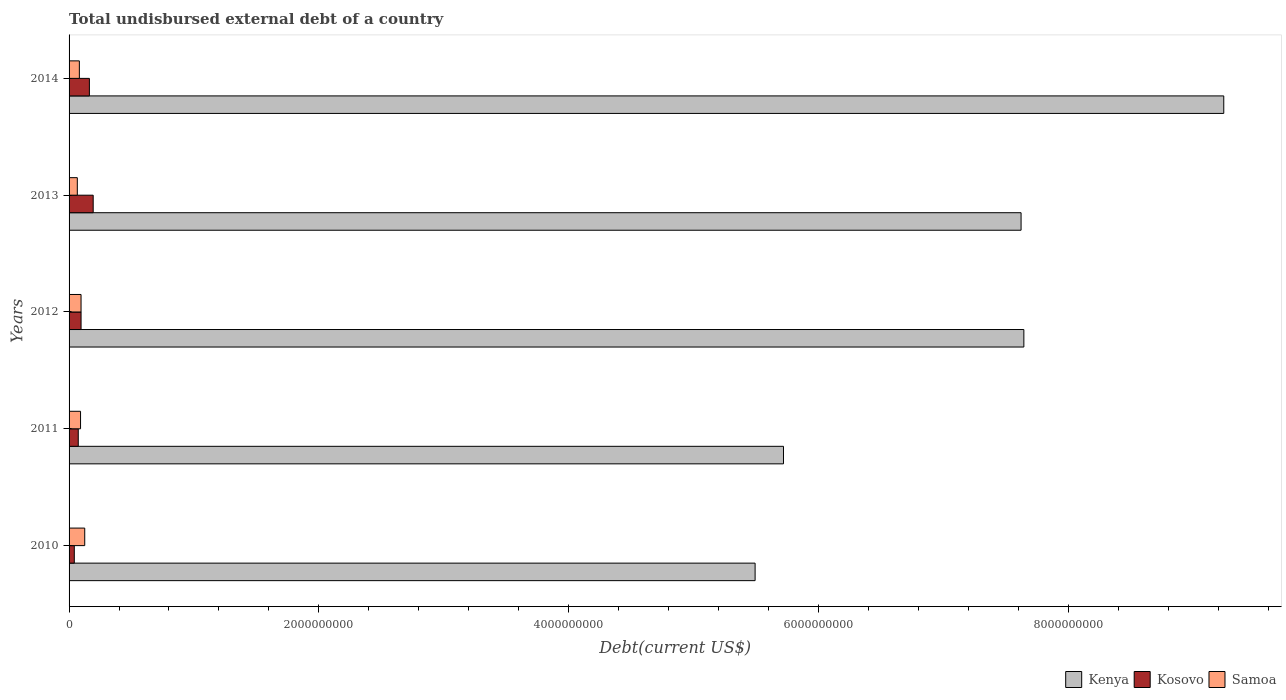How many groups of bars are there?
Keep it short and to the point. 5. How many bars are there on the 2nd tick from the bottom?
Provide a short and direct response. 3. What is the label of the 5th group of bars from the top?
Your answer should be very brief. 2010. What is the total undisbursed external debt in Kenya in 2011?
Your response must be concise. 5.72e+09. Across all years, what is the maximum total undisbursed external debt in Samoa?
Your answer should be compact. 1.25e+08. Across all years, what is the minimum total undisbursed external debt in Samoa?
Your response must be concise. 6.60e+07. In which year was the total undisbursed external debt in Kenya maximum?
Offer a very short reply. 2014. In which year was the total undisbursed external debt in Kenya minimum?
Make the answer very short. 2010. What is the total total undisbursed external debt in Kosovo in the graph?
Your response must be concise. 5.67e+08. What is the difference between the total undisbursed external debt in Kenya in 2011 and that in 2012?
Offer a very short reply. -1.92e+09. What is the difference between the total undisbursed external debt in Kosovo in 2011 and the total undisbursed external debt in Samoa in 2012?
Keep it short and to the point. -2.23e+07. What is the average total undisbursed external debt in Samoa per year?
Your response must be concise. 9.23e+07. In the year 2011, what is the difference between the total undisbursed external debt in Kosovo and total undisbursed external debt in Samoa?
Make the answer very short. -1.83e+07. What is the ratio of the total undisbursed external debt in Kosovo in 2011 to that in 2012?
Offer a terse response. 0.77. Is the difference between the total undisbursed external debt in Kosovo in 2010 and 2011 greater than the difference between the total undisbursed external debt in Samoa in 2010 and 2011?
Provide a short and direct response. No. What is the difference between the highest and the second highest total undisbursed external debt in Kosovo?
Provide a succinct answer. 3.04e+07. What is the difference between the highest and the lowest total undisbursed external debt in Samoa?
Offer a terse response. 5.94e+07. Is the sum of the total undisbursed external debt in Kosovo in 2010 and 2011 greater than the maximum total undisbursed external debt in Samoa across all years?
Provide a short and direct response. No. What does the 1st bar from the top in 2012 represents?
Offer a very short reply. Samoa. What does the 3rd bar from the bottom in 2013 represents?
Your answer should be very brief. Samoa. How many bars are there?
Your answer should be compact. 15. How many years are there in the graph?
Offer a very short reply. 5. Are the values on the major ticks of X-axis written in scientific E-notation?
Provide a succinct answer. No. Does the graph contain grids?
Make the answer very short. No. What is the title of the graph?
Ensure brevity in your answer.  Total undisbursed external debt of a country. Does "Tonga" appear as one of the legend labels in the graph?
Keep it short and to the point. No. What is the label or title of the X-axis?
Offer a very short reply. Debt(current US$). What is the label or title of the Y-axis?
Your answer should be very brief. Years. What is the Debt(current US$) in Kenya in 2010?
Ensure brevity in your answer.  5.49e+09. What is the Debt(current US$) of Kosovo in 2010?
Your answer should be very brief. 4.18e+07. What is the Debt(current US$) of Samoa in 2010?
Provide a short and direct response. 1.25e+08. What is the Debt(current US$) in Kenya in 2011?
Offer a very short reply. 5.72e+09. What is the Debt(current US$) in Kosovo in 2011?
Make the answer very short. 7.36e+07. What is the Debt(current US$) of Samoa in 2011?
Offer a terse response. 9.19e+07. What is the Debt(current US$) of Kenya in 2012?
Keep it short and to the point. 7.64e+09. What is the Debt(current US$) in Kosovo in 2012?
Give a very brief answer. 9.60e+07. What is the Debt(current US$) of Samoa in 2012?
Your answer should be very brief. 9.59e+07. What is the Debt(current US$) of Kenya in 2013?
Provide a succinct answer. 7.62e+09. What is the Debt(current US$) in Kosovo in 2013?
Your answer should be very brief. 1.93e+08. What is the Debt(current US$) in Samoa in 2013?
Provide a succinct answer. 6.60e+07. What is the Debt(current US$) of Kenya in 2014?
Keep it short and to the point. 9.25e+09. What is the Debt(current US$) in Kosovo in 2014?
Offer a very short reply. 1.63e+08. What is the Debt(current US$) of Samoa in 2014?
Provide a short and direct response. 8.24e+07. Across all years, what is the maximum Debt(current US$) in Kenya?
Make the answer very short. 9.25e+09. Across all years, what is the maximum Debt(current US$) of Kosovo?
Ensure brevity in your answer.  1.93e+08. Across all years, what is the maximum Debt(current US$) of Samoa?
Offer a terse response. 1.25e+08. Across all years, what is the minimum Debt(current US$) of Kenya?
Offer a terse response. 5.49e+09. Across all years, what is the minimum Debt(current US$) of Kosovo?
Offer a very short reply. 4.18e+07. Across all years, what is the minimum Debt(current US$) in Samoa?
Offer a very short reply. 6.60e+07. What is the total Debt(current US$) of Kenya in the graph?
Provide a short and direct response. 3.57e+1. What is the total Debt(current US$) of Kosovo in the graph?
Offer a terse response. 5.67e+08. What is the total Debt(current US$) of Samoa in the graph?
Your answer should be very brief. 4.62e+08. What is the difference between the Debt(current US$) of Kenya in 2010 and that in 2011?
Provide a short and direct response. -2.27e+08. What is the difference between the Debt(current US$) in Kosovo in 2010 and that in 2011?
Give a very brief answer. -3.18e+07. What is the difference between the Debt(current US$) in Samoa in 2010 and that in 2011?
Offer a terse response. 3.35e+07. What is the difference between the Debt(current US$) of Kenya in 2010 and that in 2012?
Make the answer very short. -2.15e+09. What is the difference between the Debt(current US$) of Kosovo in 2010 and that in 2012?
Make the answer very short. -5.42e+07. What is the difference between the Debt(current US$) of Samoa in 2010 and that in 2012?
Ensure brevity in your answer.  2.95e+07. What is the difference between the Debt(current US$) of Kenya in 2010 and that in 2013?
Your response must be concise. -2.13e+09. What is the difference between the Debt(current US$) in Kosovo in 2010 and that in 2013?
Make the answer very short. -1.51e+08. What is the difference between the Debt(current US$) of Samoa in 2010 and that in 2013?
Give a very brief answer. 5.94e+07. What is the difference between the Debt(current US$) in Kenya in 2010 and that in 2014?
Give a very brief answer. -3.75e+09. What is the difference between the Debt(current US$) of Kosovo in 2010 and that in 2014?
Your answer should be compact. -1.21e+08. What is the difference between the Debt(current US$) of Samoa in 2010 and that in 2014?
Your response must be concise. 4.30e+07. What is the difference between the Debt(current US$) in Kenya in 2011 and that in 2012?
Provide a succinct answer. -1.92e+09. What is the difference between the Debt(current US$) of Kosovo in 2011 and that in 2012?
Ensure brevity in your answer.  -2.24e+07. What is the difference between the Debt(current US$) in Samoa in 2011 and that in 2012?
Ensure brevity in your answer.  -4.03e+06. What is the difference between the Debt(current US$) in Kenya in 2011 and that in 2013?
Your answer should be very brief. -1.90e+09. What is the difference between the Debt(current US$) in Kosovo in 2011 and that in 2013?
Keep it short and to the point. -1.20e+08. What is the difference between the Debt(current US$) in Samoa in 2011 and that in 2013?
Your answer should be very brief. 2.58e+07. What is the difference between the Debt(current US$) of Kenya in 2011 and that in 2014?
Offer a terse response. -3.53e+09. What is the difference between the Debt(current US$) in Kosovo in 2011 and that in 2014?
Provide a short and direct response. -8.91e+07. What is the difference between the Debt(current US$) in Samoa in 2011 and that in 2014?
Ensure brevity in your answer.  9.43e+06. What is the difference between the Debt(current US$) of Kenya in 2012 and that in 2013?
Make the answer very short. 2.23e+07. What is the difference between the Debt(current US$) of Kosovo in 2012 and that in 2013?
Provide a succinct answer. -9.72e+07. What is the difference between the Debt(current US$) of Samoa in 2012 and that in 2013?
Keep it short and to the point. 2.99e+07. What is the difference between the Debt(current US$) in Kenya in 2012 and that in 2014?
Offer a very short reply. -1.60e+09. What is the difference between the Debt(current US$) in Kosovo in 2012 and that in 2014?
Make the answer very short. -6.67e+07. What is the difference between the Debt(current US$) of Samoa in 2012 and that in 2014?
Make the answer very short. 1.35e+07. What is the difference between the Debt(current US$) of Kenya in 2013 and that in 2014?
Give a very brief answer. -1.62e+09. What is the difference between the Debt(current US$) in Kosovo in 2013 and that in 2014?
Give a very brief answer. 3.04e+07. What is the difference between the Debt(current US$) in Samoa in 2013 and that in 2014?
Your answer should be very brief. -1.64e+07. What is the difference between the Debt(current US$) of Kenya in 2010 and the Debt(current US$) of Kosovo in 2011?
Offer a terse response. 5.42e+09. What is the difference between the Debt(current US$) of Kenya in 2010 and the Debt(current US$) of Samoa in 2011?
Ensure brevity in your answer.  5.40e+09. What is the difference between the Debt(current US$) of Kosovo in 2010 and the Debt(current US$) of Samoa in 2011?
Offer a terse response. -5.00e+07. What is the difference between the Debt(current US$) of Kenya in 2010 and the Debt(current US$) of Kosovo in 2012?
Offer a very short reply. 5.40e+09. What is the difference between the Debt(current US$) of Kenya in 2010 and the Debt(current US$) of Samoa in 2012?
Your answer should be compact. 5.40e+09. What is the difference between the Debt(current US$) in Kosovo in 2010 and the Debt(current US$) in Samoa in 2012?
Your response must be concise. -5.41e+07. What is the difference between the Debt(current US$) in Kenya in 2010 and the Debt(current US$) in Kosovo in 2013?
Offer a terse response. 5.30e+09. What is the difference between the Debt(current US$) in Kenya in 2010 and the Debt(current US$) in Samoa in 2013?
Provide a short and direct response. 5.43e+09. What is the difference between the Debt(current US$) of Kosovo in 2010 and the Debt(current US$) of Samoa in 2013?
Keep it short and to the point. -2.42e+07. What is the difference between the Debt(current US$) in Kenya in 2010 and the Debt(current US$) in Kosovo in 2014?
Your answer should be very brief. 5.33e+09. What is the difference between the Debt(current US$) in Kenya in 2010 and the Debt(current US$) in Samoa in 2014?
Your response must be concise. 5.41e+09. What is the difference between the Debt(current US$) in Kosovo in 2010 and the Debt(current US$) in Samoa in 2014?
Your answer should be compact. -4.06e+07. What is the difference between the Debt(current US$) of Kenya in 2011 and the Debt(current US$) of Kosovo in 2012?
Give a very brief answer. 5.62e+09. What is the difference between the Debt(current US$) in Kenya in 2011 and the Debt(current US$) in Samoa in 2012?
Provide a short and direct response. 5.62e+09. What is the difference between the Debt(current US$) in Kosovo in 2011 and the Debt(current US$) in Samoa in 2012?
Provide a short and direct response. -2.23e+07. What is the difference between the Debt(current US$) in Kenya in 2011 and the Debt(current US$) in Kosovo in 2013?
Offer a terse response. 5.53e+09. What is the difference between the Debt(current US$) of Kenya in 2011 and the Debt(current US$) of Samoa in 2013?
Give a very brief answer. 5.65e+09. What is the difference between the Debt(current US$) in Kosovo in 2011 and the Debt(current US$) in Samoa in 2013?
Make the answer very short. 7.57e+06. What is the difference between the Debt(current US$) in Kenya in 2011 and the Debt(current US$) in Kosovo in 2014?
Offer a terse response. 5.56e+09. What is the difference between the Debt(current US$) of Kenya in 2011 and the Debt(current US$) of Samoa in 2014?
Keep it short and to the point. 5.64e+09. What is the difference between the Debt(current US$) of Kosovo in 2011 and the Debt(current US$) of Samoa in 2014?
Provide a short and direct response. -8.83e+06. What is the difference between the Debt(current US$) in Kenya in 2012 and the Debt(current US$) in Kosovo in 2013?
Ensure brevity in your answer.  7.45e+09. What is the difference between the Debt(current US$) in Kenya in 2012 and the Debt(current US$) in Samoa in 2013?
Offer a very short reply. 7.58e+09. What is the difference between the Debt(current US$) in Kosovo in 2012 and the Debt(current US$) in Samoa in 2013?
Provide a short and direct response. 3.00e+07. What is the difference between the Debt(current US$) in Kenya in 2012 and the Debt(current US$) in Kosovo in 2014?
Your answer should be very brief. 7.48e+09. What is the difference between the Debt(current US$) in Kenya in 2012 and the Debt(current US$) in Samoa in 2014?
Provide a short and direct response. 7.56e+09. What is the difference between the Debt(current US$) of Kosovo in 2012 and the Debt(current US$) of Samoa in 2014?
Your answer should be very brief. 1.36e+07. What is the difference between the Debt(current US$) of Kenya in 2013 and the Debt(current US$) of Kosovo in 2014?
Ensure brevity in your answer.  7.46e+09. What is the difference between the Debt(current US$) of Kenya in 2013 and the Debt(current US$) of Samoa in 2014?
Your answer should be compact. 7.54e+09. What is the difference between the Debt(current US$) in Kosovo in 2013 and the Debt(current US$) in Samoa in 2014?
Ensure brevity in your answer.  1.11e+08. What is the average Debt(current US$) in Kenya per year?
Your answer should be compact. 7.15e+09. What is the average Debt(current US$) of Kosovo per year?
Your answer should be compact. 1.13e+08. What is the average Debt(current US$) in Samoa per year?
Your answer should be very brief. 9.23e+07. In the year 2010, what is the difference between the Debt(current US$) of Kenya and Debt(current US$) of Kosovo?
Offer a very short reply. 5.45e+09. In the year 2010, what is the difference between the Debt(current US$) in Kenya and Debt(current US$) in Samoa?
Offer a very short reply. 5.37e+09. In the year 2010, what is the difference between the Debt(current US$) of Kosovo and Debt(current US$) of Samoa?
Offer a terse response. -8.36e+07. In the year 2011, what is the difference between the Debt(current US$) in Kenya and Debt(current US$) in Kosovo?
Provide a succinct answer. 5.65e+09. In the year 2011, what is the difference between the Debt(current US$) in Kenya and Debt(current US$) in Samoa?
Offer a terse response. 5.63e+09. In the year 2011, what is the difference between the Debt(current US$) of Kosovo and Debt(current US$) of Samoa?
Give a very brief answer. -1.83e+07. In the year 2012, what is the difference between the Debt(current US$) of Kenya and Debt(current US$) of Kosovo?
Your response must be concise. 7.55e+09. In the year 2012, what is the difference between the Debt(current US$) of Kenya and Debt(current US$) of Samoa?
Offer a terse response. 7.55e+09. In the year 2012, what is the difference between the Debt(current US$) in Kosovo and Debt(current US$) in Samoa?
Your answer should be very brief. 1.13e+05. In the year 2013, what is the difference between the Debt(current US$) in Kenya and Debt(current US$) in Kosovo?
Provide a succinct answer. 7.43e+09. In the year 2013, what is the difference between the Debt(current US$) of Kenya and Debt(current US$) of Samoa?
Your answer should be very brief. 7.56e+09. In the year 2013, what is the difference between the Debt(current US$) in Kosovo and Debt(current US$) in Samoa?
Ensure brevity in your answer.  1.27e+08. In the year 2014, what is the difference between the Debt(current US$) in Kenya and Debt(current US$) in Kosovo?
Offer a terse response. 9.08e+09. In the year 2014, what is the difference between the Debt(current US$) in Kenya and Debt(current US$) in Samoa?
Your answer should be compact. 9.16e+09. In the year 2014, what is the difference between the Debt(current US$) of Kosovo and Debt(current US$) of Samoa?
Keep it short and to the point. 8.03e+07. What is the ratio of the Debt(current US$) in Kenya in 2010 to that in 2011?
Offer a terse response. 0.96. What is the ratio of the Debt(current US$) in Kosovo in 2010 to that in 2011?
Offer a terse response. 0.57. What is the ratio of the Debt(current US$) of Samoa in 2010 to that in 2011?
Ensure brevity in your answer.  1.37. What is the ratio of the Debt(current US$) in Kenya in 2010 to that in 2012?
Keep it short and to the point. 0.72. What is the ratio of the Debt(current US$) of Kosovo in 2010 to that in 2012?
Offer a very short reply. 0.44. What is the ratio of the Debt(current US$) in Samoa in 2010 to that in 2012?
Your response must be concise. 1.31. What is the ratio of the Debt(current US$) in Kenya in 2010 to that in 2013?
Give a very brief answer. 0.72. What is the ratio of the Debt(current US$) in Kosovo in 2010 to that in 2013?
Offer a very short reply. 0.22. What is the ratio of the Debt(current US$) in Samoa in 2010 to that in 2013?
Ensure brevity in your answer.  1.9. What is the ratio of the Debt(current US$) in Kenya in 2010 to that in 2014?
Make the answer very short. 0.59. What is the ratio of the Debt(current US$) in Kosovo in 2010 to that in 2014?
Make the answer very short. 0.26. What is the ratio of the Debt(current US$) of Samoa in 2010 to that in 2014?
Give a very brief answer. 1.52. What is the ratio of the Debt(current US$) in Kenya in 2011 to that in 2012?
Make the answer very short. 0.75. What is the ratio of the Debt(current US$) of Kosovo in 2011 to that in 2012?
Offer a very short reply. 0.77. What is the ratio of the Debt(current US$) in Samoa in 2011 to that in 2012?
Your answer should be very brief. 0.96. What is the ratio of the Debt(current US$) in Kenya in 2011 to that in 2013?
Give a very brief answer. 0.75. What is the ratio of the Debt(current US$) of Kosovo in 2011 to that in 2013?
Offer a very short reply. 0.38. What is the ratio of the Debt(current US$) of Samoa in 2011 to that in 2013?
Your answer should be very brief. 1.39. What is the ratio of the Debt(current US$) of Kenya in 2011 to that in 2014?
Keep it short and to the point. 0.62. What is the ratio of the Debt(current US$) in Kosovo in 2011 to that in 2014?
Ensure brevity in your answer.  0.45. What is the ratio of the Debt(current US$) in Samoa in 2011 to that in 2014?
Your answer should be very brief. 1.11. What is the ratio of the Debt(current US$) in Kosovo in 2012 to that in 2013?
Your answer should be compact. 0.5. What is the ratio of the Debt(current US$) in Samoa in 2012 to that in 2013?
Provide a succinct answer. 1.45. What is the ratio of the Debt(current US$) of Kenya in 2012 to that in 2014?
Offer a very short reply. 0.83. What is the ratio of the Debt(current US$) of Kosovo in 2012 to that in 2014?
Give a very brief answer. 0.59. What is the ratio of the Debt(current US$) of Samoa in 2012 to that in 2014?
Offer a terse response. 1.16. What is the ratio of the Debt(current US$) of Kenya in 2013 to that in 2014?
Offer a terse response. 0.82. What is the ratio of the Debt(current US$) in Kosovo in 2013 to that in 2014?
Keep it short and to the point. 1.19. What is the ratio of the Debt(current US$) in Samoa in 2013 to that in 2014?
Offer a very short reply. 0.8. What is the difference between the highest and the second highest Debt(current US$) in Kenya?
Keep it short and to the point. 1.60e+09. What is the difference between the highest and the second highest Debt(current US$) of Kosovo?
Ensure brevity in your answer.  3.04e+07. What is the difference between the highest and the second highest Debt(current US$) of Samoa?
Keep it short and to the point. 2.95e+07. What is the difference between the highest and the lowest Debt(current US$) of Kenya?
Your answer should be compact. 3.75e+09. What is the difference between the highest and the lowest Debt(current US$) of Kosovo?
Ensure brevity in your answer.  1.51e+08. What is the difference between the highest and the lowest Debt(current US$) in Samoa?
Your response must be concise. 5.94e+07. 